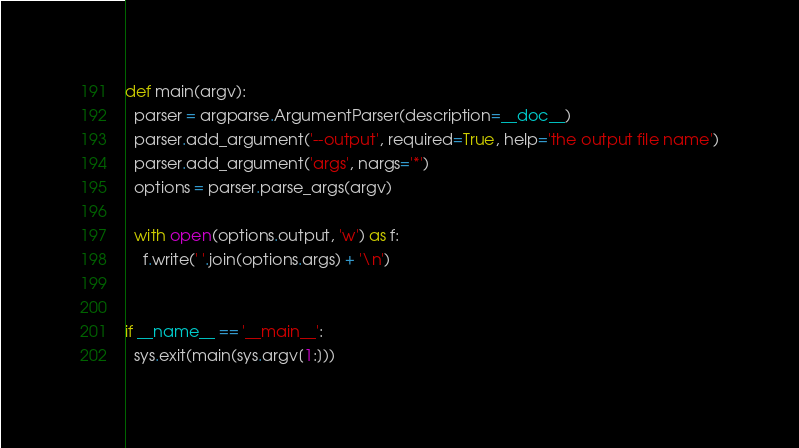Convert code to text. <code><loc_0><loc_0><loc_500><loc_500><_Python_>

def main(argv):
  parser = argparse.ArgumentParser(description=__doc__)
  parser.add_argument('--output', required=True, help='the output file name')
  parser.add_argument('args', nargs='*')
  options = parser.parse_args(argv)

  with open(options.output, 'w') as f:
    f.write(' '.join(options.args) + '\n')


if __name__ == '__main__':
  sys.exit(main(sys.argv[1:]))
</code> 